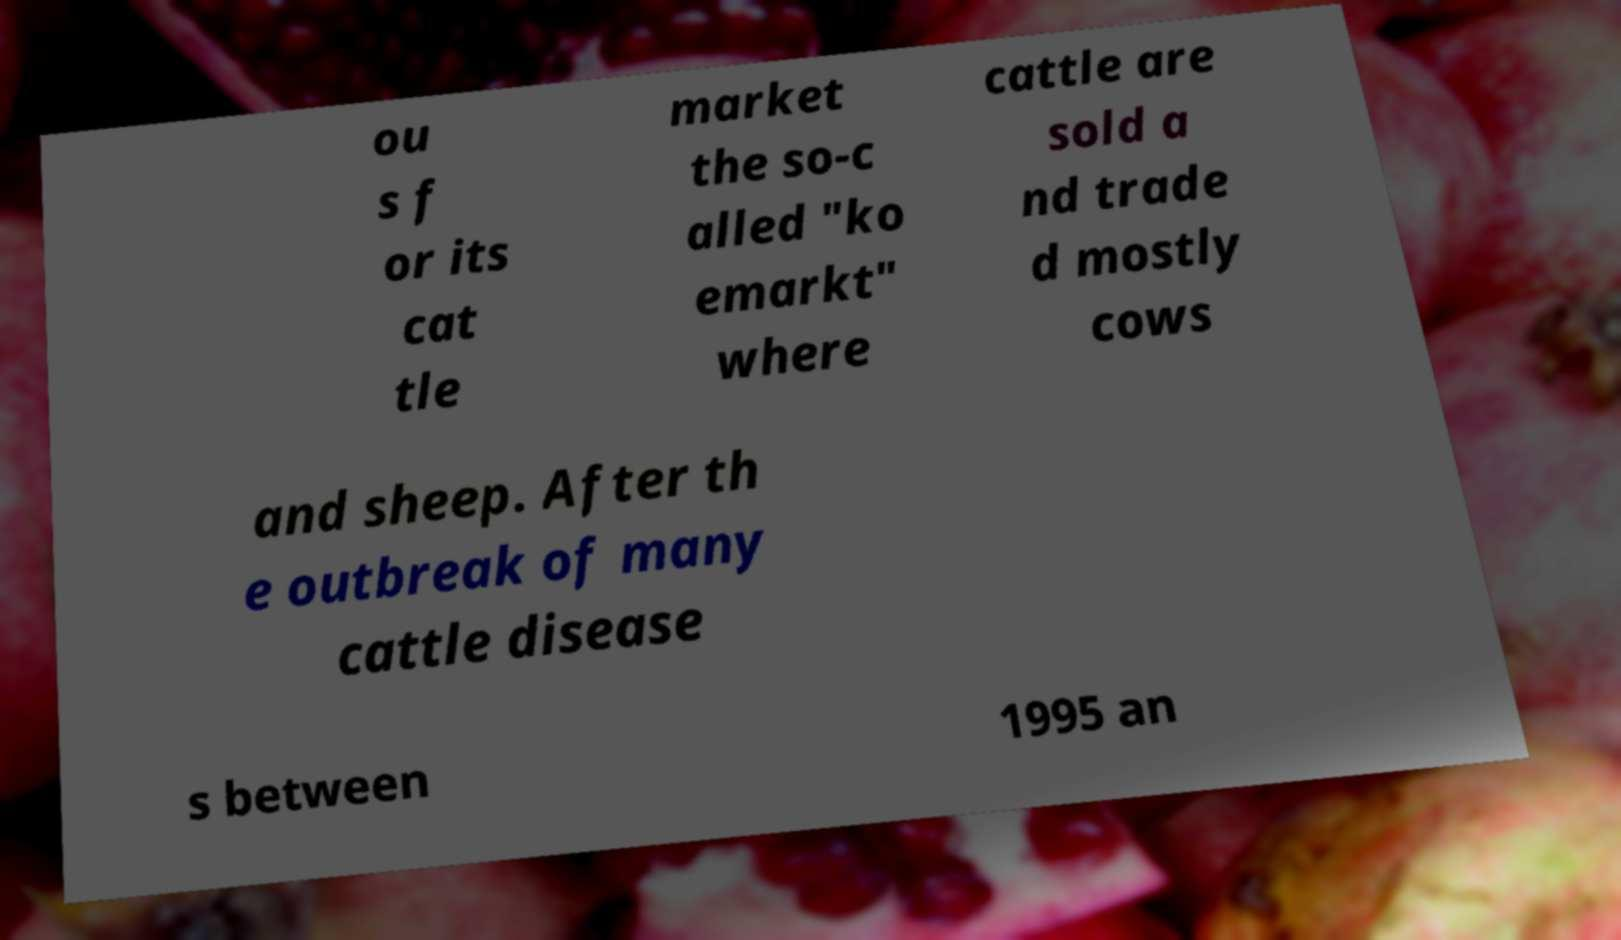Could you assist in decoding the text presented in this image and type it out clearly? ou s f or its cat tle market the so-c alled "ko emarkt" where cattle are sold a nd trade d mostly cows and sheep. After th e outbreak of many cattle disease s between 1995 an 